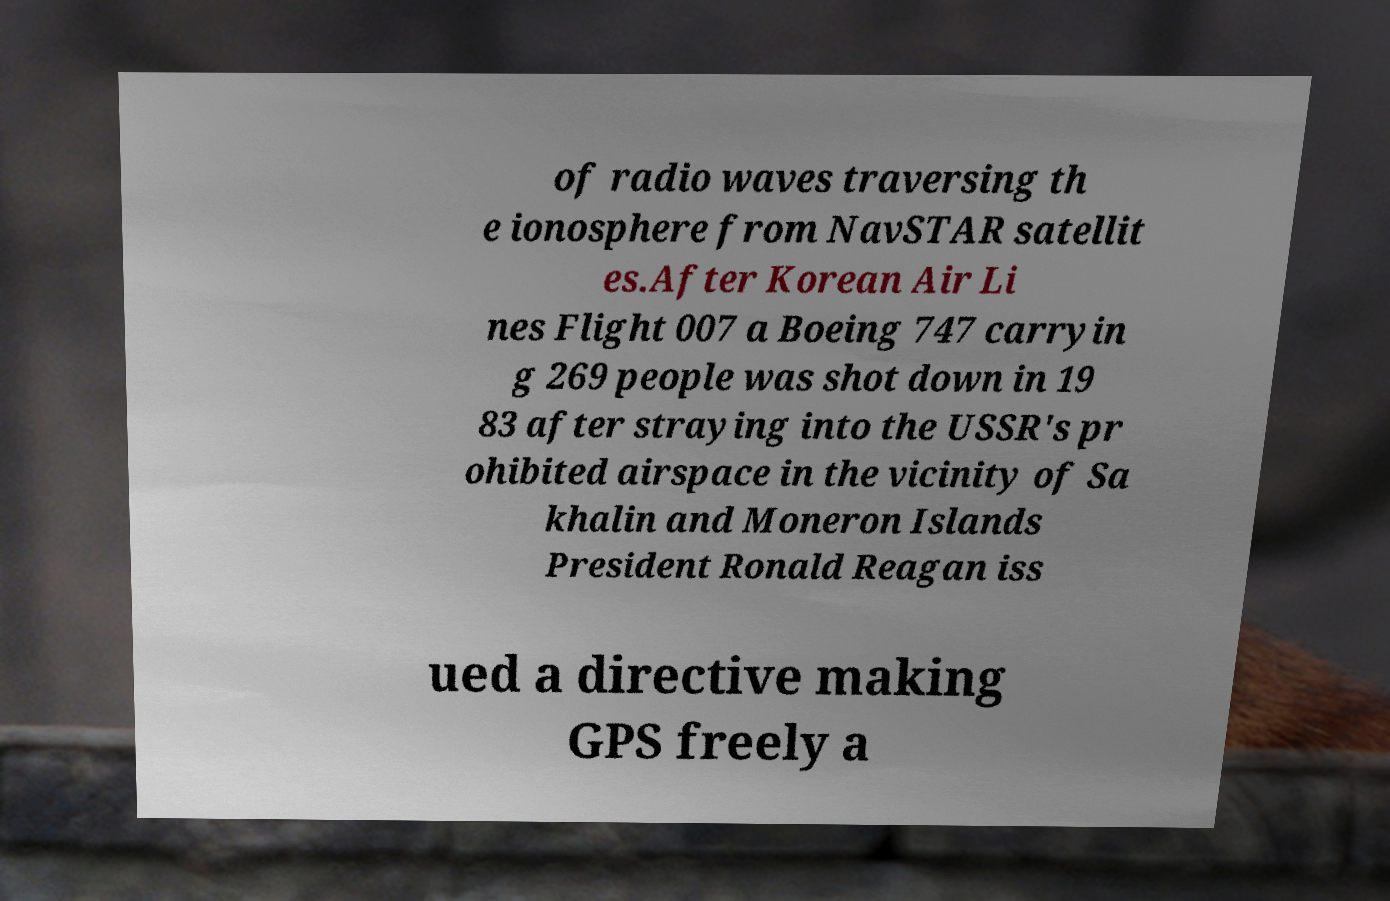For documentation purposes, I need the text within this image transcribed. Could you provide that? of radio waves traversing th e ionosphere from NavSTAR satellit es.After Korean Air Li nes Flight 007 a Boeing 747 carryin g 269 people was shot down in 19 83 after straying into the USSR's pr ohibited airspace in the vicinity of Sa khalin and Moneron Islands President Ronald Reagan iss ued a directive making GPS freely a 